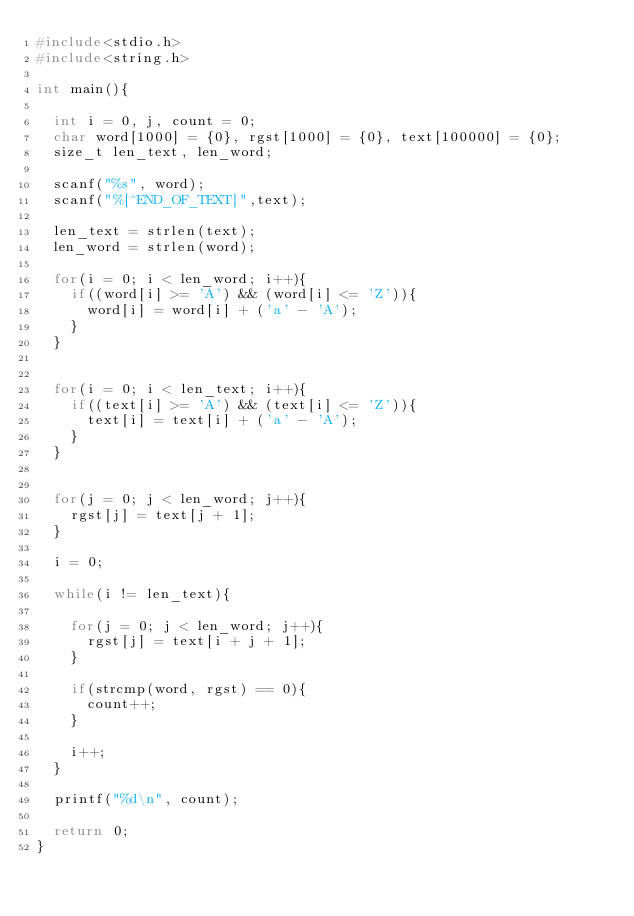Convert code to text. <code><loc_0><loc_0><loc_500><loc_500><_C_>#include<stdio.h>
#include<string.h>

int main(){

	int i = 0, j, count = 0;
	char word[1000] = {0}, rgst[1000] = {0}, text[100000] = {0};
	size_t len_text, len_word;

	scanf("%s", word);
	scanf("%[^END_OF_TEXT]",text);

	len_text = strlen(text);
	len_word = strlen(word);

	for(i = 0; i < len_word; i++){
		if((word[i] >= 'A') && (word[i] <= 'Z')){
			word[i] = word[i] + ('a' - 'A');
		}
	}


	for(i = 0; i < len_text; i++){
		if((text[i] >= 'A') && (text[i] <= 'Z')){
			text[i] = text[i] + ('a' - 'A');
		}
	}

	
	for(j = 0; j < len_word; j++){
		rgst[j] = text[j + 1];
	}

	i = 0;
	
	while(i != len_text){

		for(j = 0; j < len_word; j++){
			rgst[j] = text[i + j + 1];
		}

		if(strcmp(word, rgst) == 0){
			count++;
		}
		
		i++;
	}

	printf("%d\n", count);

	return 0;
}</code> 